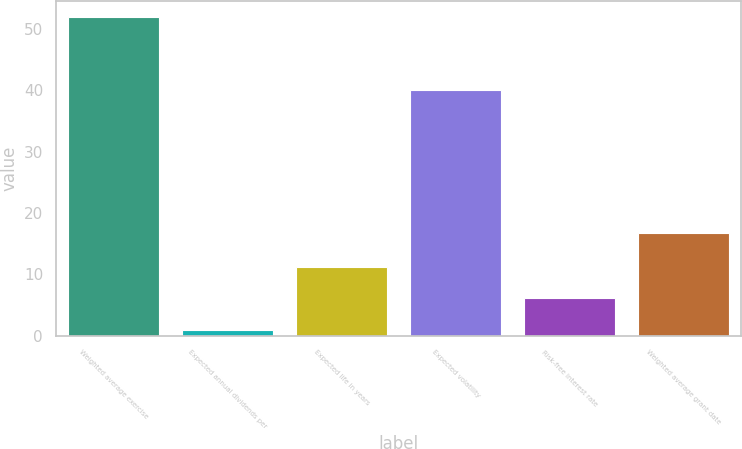Convert chart to OTSL. <chart><loc_0><loc_0><loc_500><loc_500><bar_chart><fcel>Weighted average exercise<fcel>Expected annual dividends per<fcel>Expected life in years<fcel>Expected volatility<fcel>Risk-free interest rate<fcel>Weighted average grant date<nl><fcel>51.93<fcel>1<fcel>11.18<fcel>40<fcel>6.09<fcel>16.73<nl></chart> 